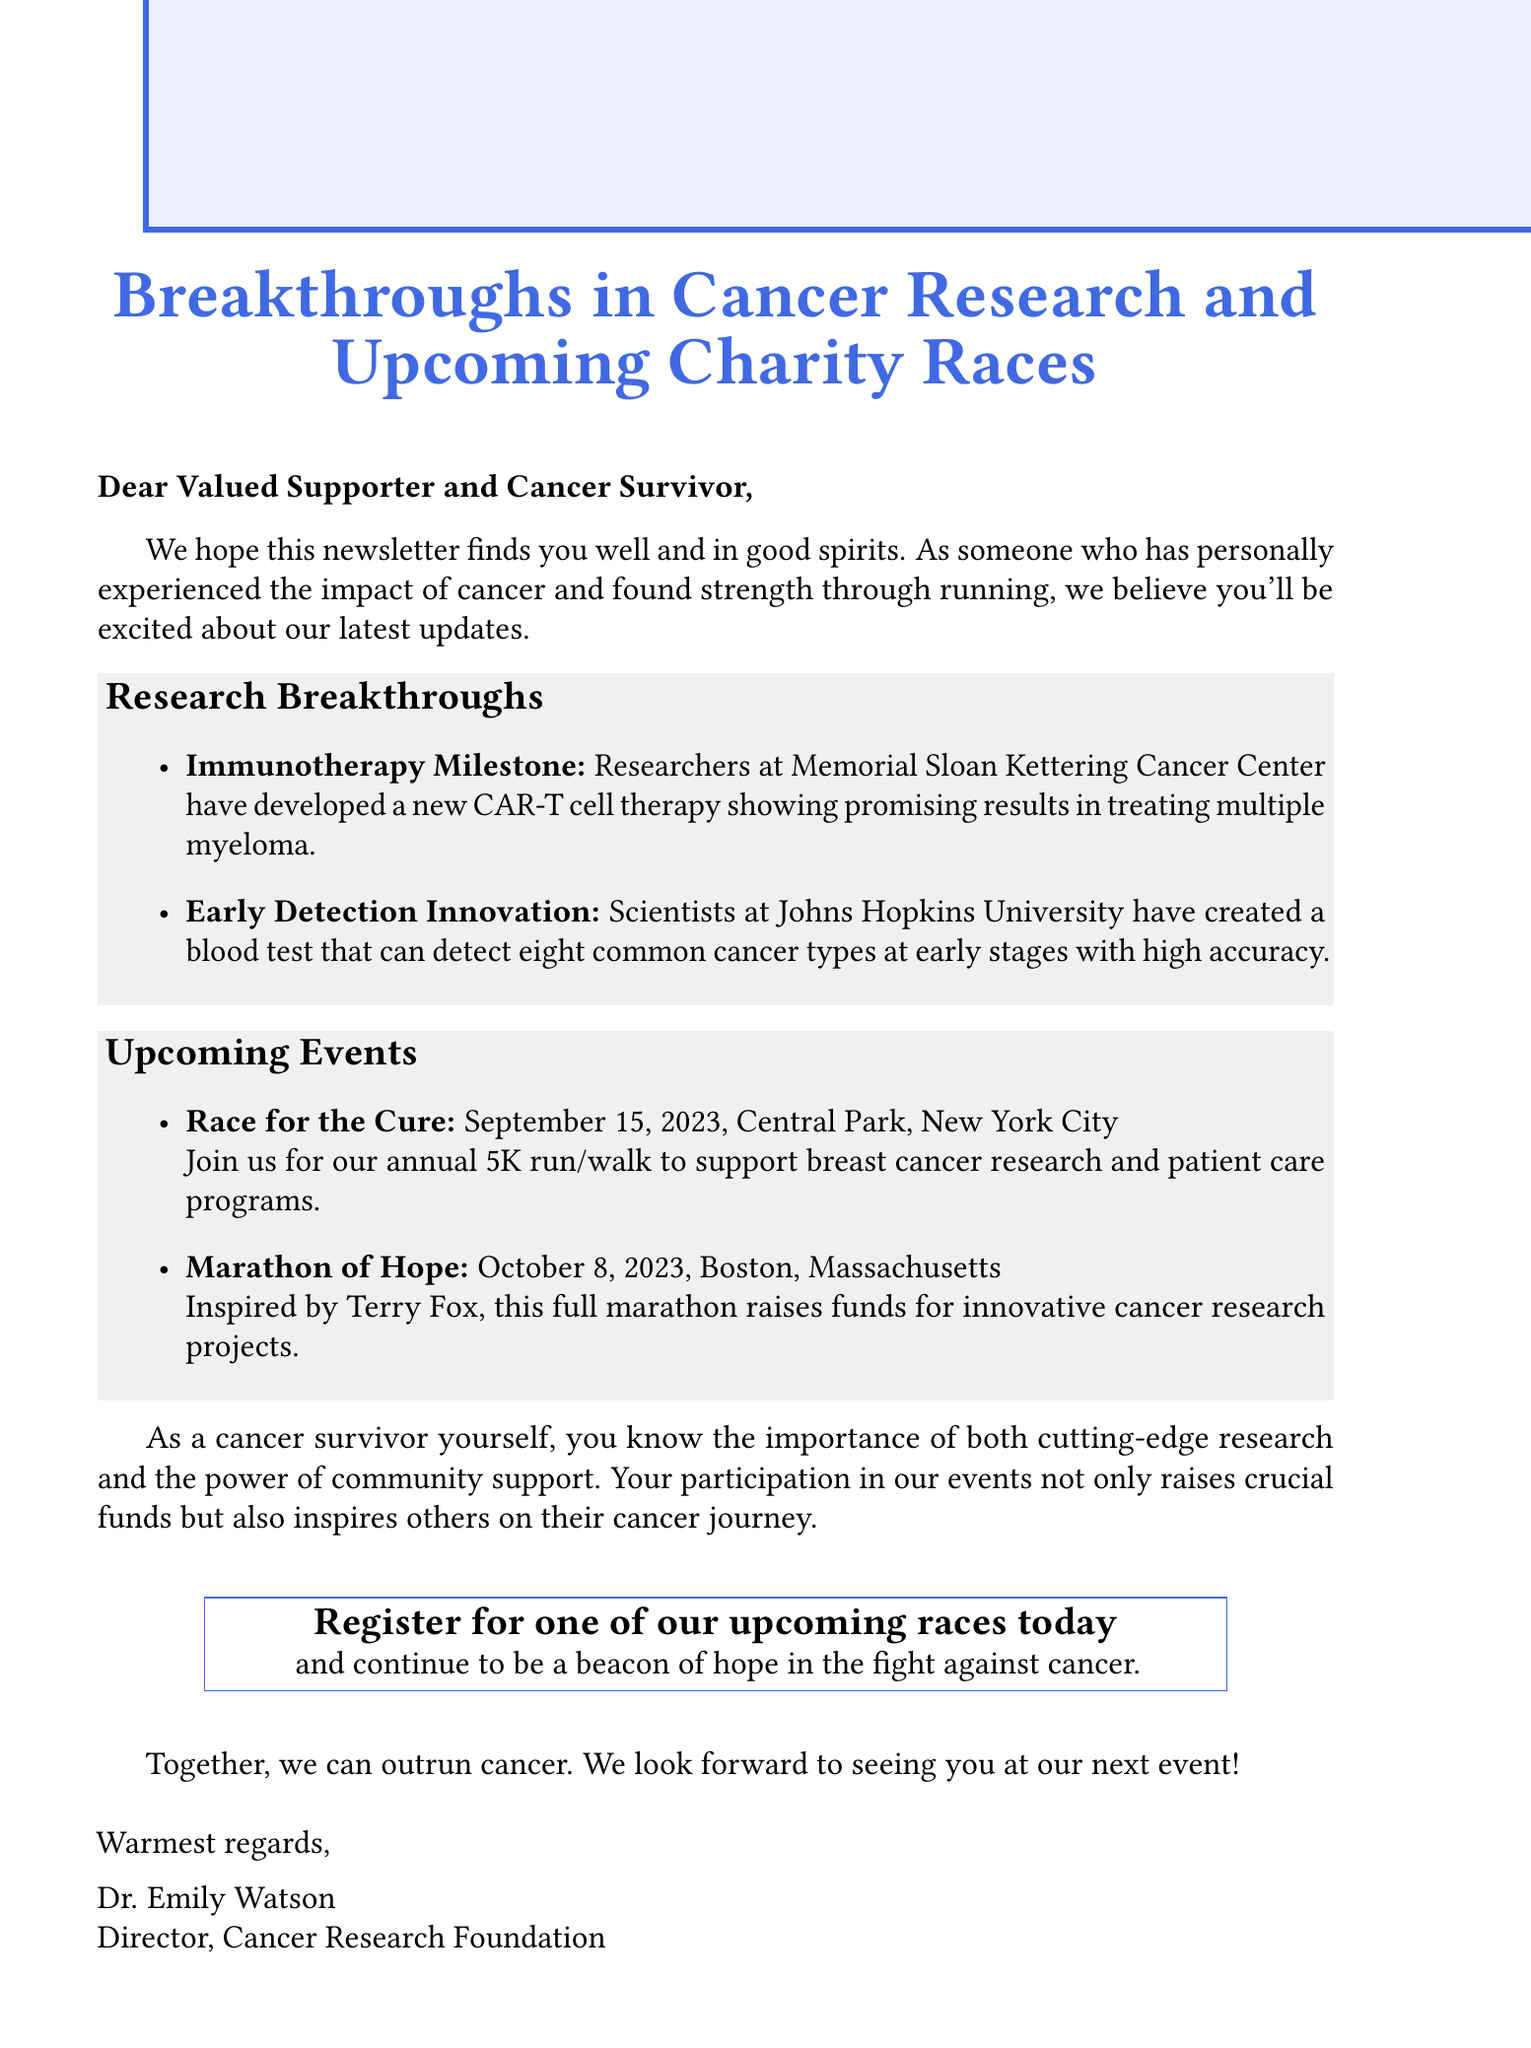What is the title of the newsletter? The title of the newsletter is prominently displayed at the top as the main heading.
Answer: Breakthroughs in Cancer Research and Upcoming Charity Races Who conducted the research for the immunotherapy milestone? The document mentions a specific institution associated with the research breakthrough.
Answer: Memorial Sloan Kettering Cancer Center What cancer types does the early detection innovation blood test target? The description specifies a certain number of cancer types that the blood test can detect.
Answer: eight When is the Race for the Cure scheduled? The document provides the date of this fundraising event.
Answer: September 15, 2023 What is the location of the Marathon of Hope? The document indicates the specific city where the event will be held.
Answer: Boston, Massachusetts Which event specifically supports breast cancer research? The document describes an event that has a focus on breast cancer.
Answer: Race for the Cure How does participation in the events impact community support? A reasoning based on the personal story highlighted in the newsletter about community and participation.
Answer: It inspires others on their cancer journey Who signed the newsletter? The document lists the name and title of the person at the end of the message.
Answer: Dr. Emily Watson 